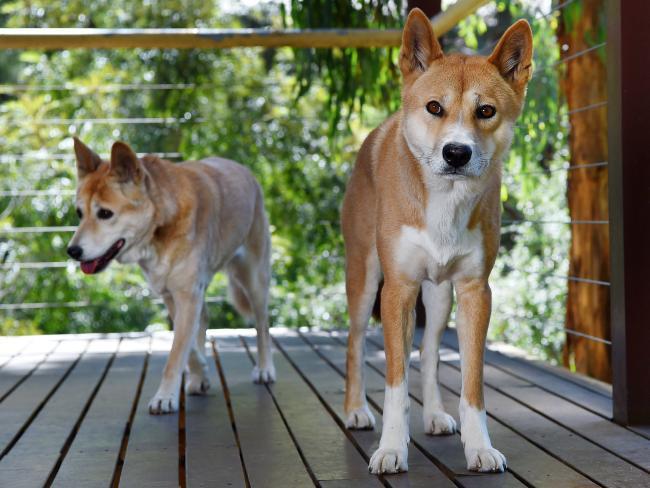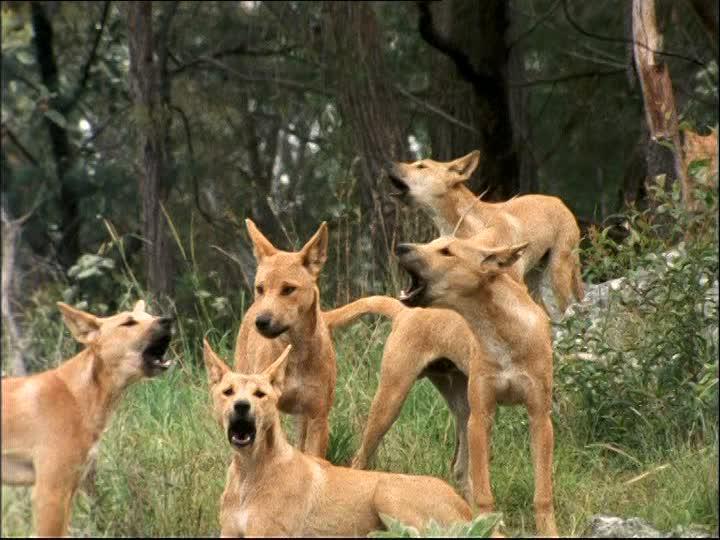The first image is the image on the left, the second image is the image on the right. Evaluate the accuracy of this statement regarding the images: "The left image contains one standing dingo and a fallen log, and the right image contains exactly two standing dingos.". Is it true? Answer yes or no. No. The first image is the image on the left, the second image is the image on the right. Analyze the images presented: Is the assertion "One of the images contains a single dog in a wooded area." valid? Answer yes or no. No. 